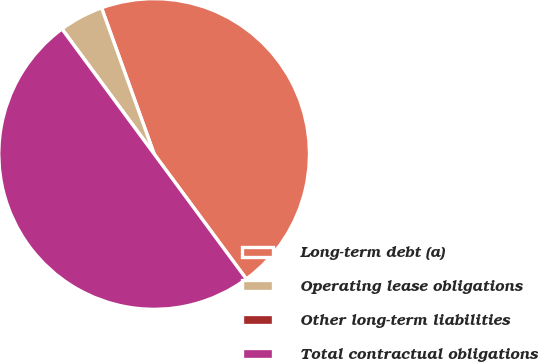Convert chart. <chart><loc_0><loc_0><loc_500><loc_500><pie_chart><fcel>Long-term debt (a)<fcel>Operating lease obligations<fcel>Other long-term liabilities<fcel>Total contractual obligations<nl><fcel>45.38%<fcel>4.62%<fcel>0.0%<fcel>50.0%<nl></chart> 